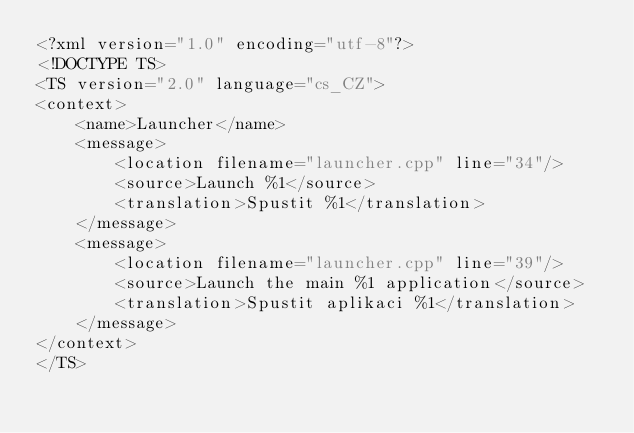<code> <loc_0><loc_0><loc_500><loc_500><_TypeScript_><?xml version="1.0" encoding="utf-8"?>
<!DOCTYPE TS>
<TS version="2.0" language="cs_CZ">
<context>
    <name>Launcher</name>
    <message>
        <location filename="launcher.cpp" line="34"/>
        <source>Launch %1</source>
        <translation>Spustit %1</translation>
    </message>
    <message>
        <location filename="launcher.cpp" line="39"/>
        <source>Launch the main %1 application</source>
        <translation>Spustit aplikaci %1</translation>
    </message>
</context>
</TS>
</code> 